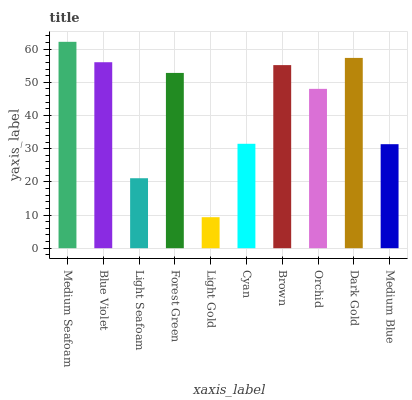Is Light Gold the minimum?
Answer yes or no. Yes. Is Medium Seafoam the maximum?
Answer yes or no. Yes. Is Blue Violet the minimum?
Answer yes or no. No. Is Blue Violet the maximum?
Answer yes or no. No. Is Medium Seafoam greater than Blue Violet?
Answer yes or no. Yes. Is Blue Violet less than Medium Seafoam?
Answer yes or no. Yes. Is Blue Violet greater than Medium Seafoam?
Answer yes or no. No. Is Medium Seafoam less than Blue Violet?
Answer yes or no. No. Is Forest Green the high median?
Answer yes or no. Yes. Is Orchid the low median?
Answer yes or no. Yes. Is Cyan the high median?
Answer yes or no. No. Is Light Seafoam the low median?
Answer yes or no. No. 